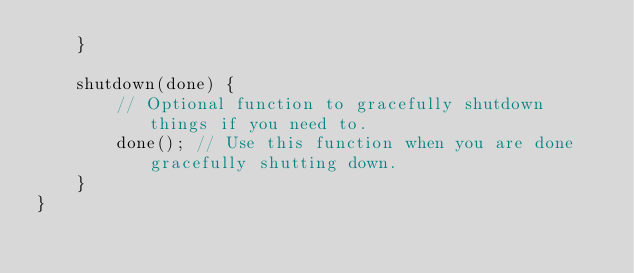<code> <loc_0><loc_0><loc_500><loc_500><_JavaScript_>    }

    shutdown(done) {
        // Optional function to gracefully shutdown things if you need to.
        done(); // Use this function when you are done gracefully shutting down.
    }
}</code> 